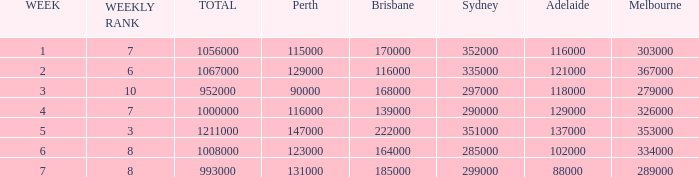What is the highest number of Brisbane viewers? 222000.0. 